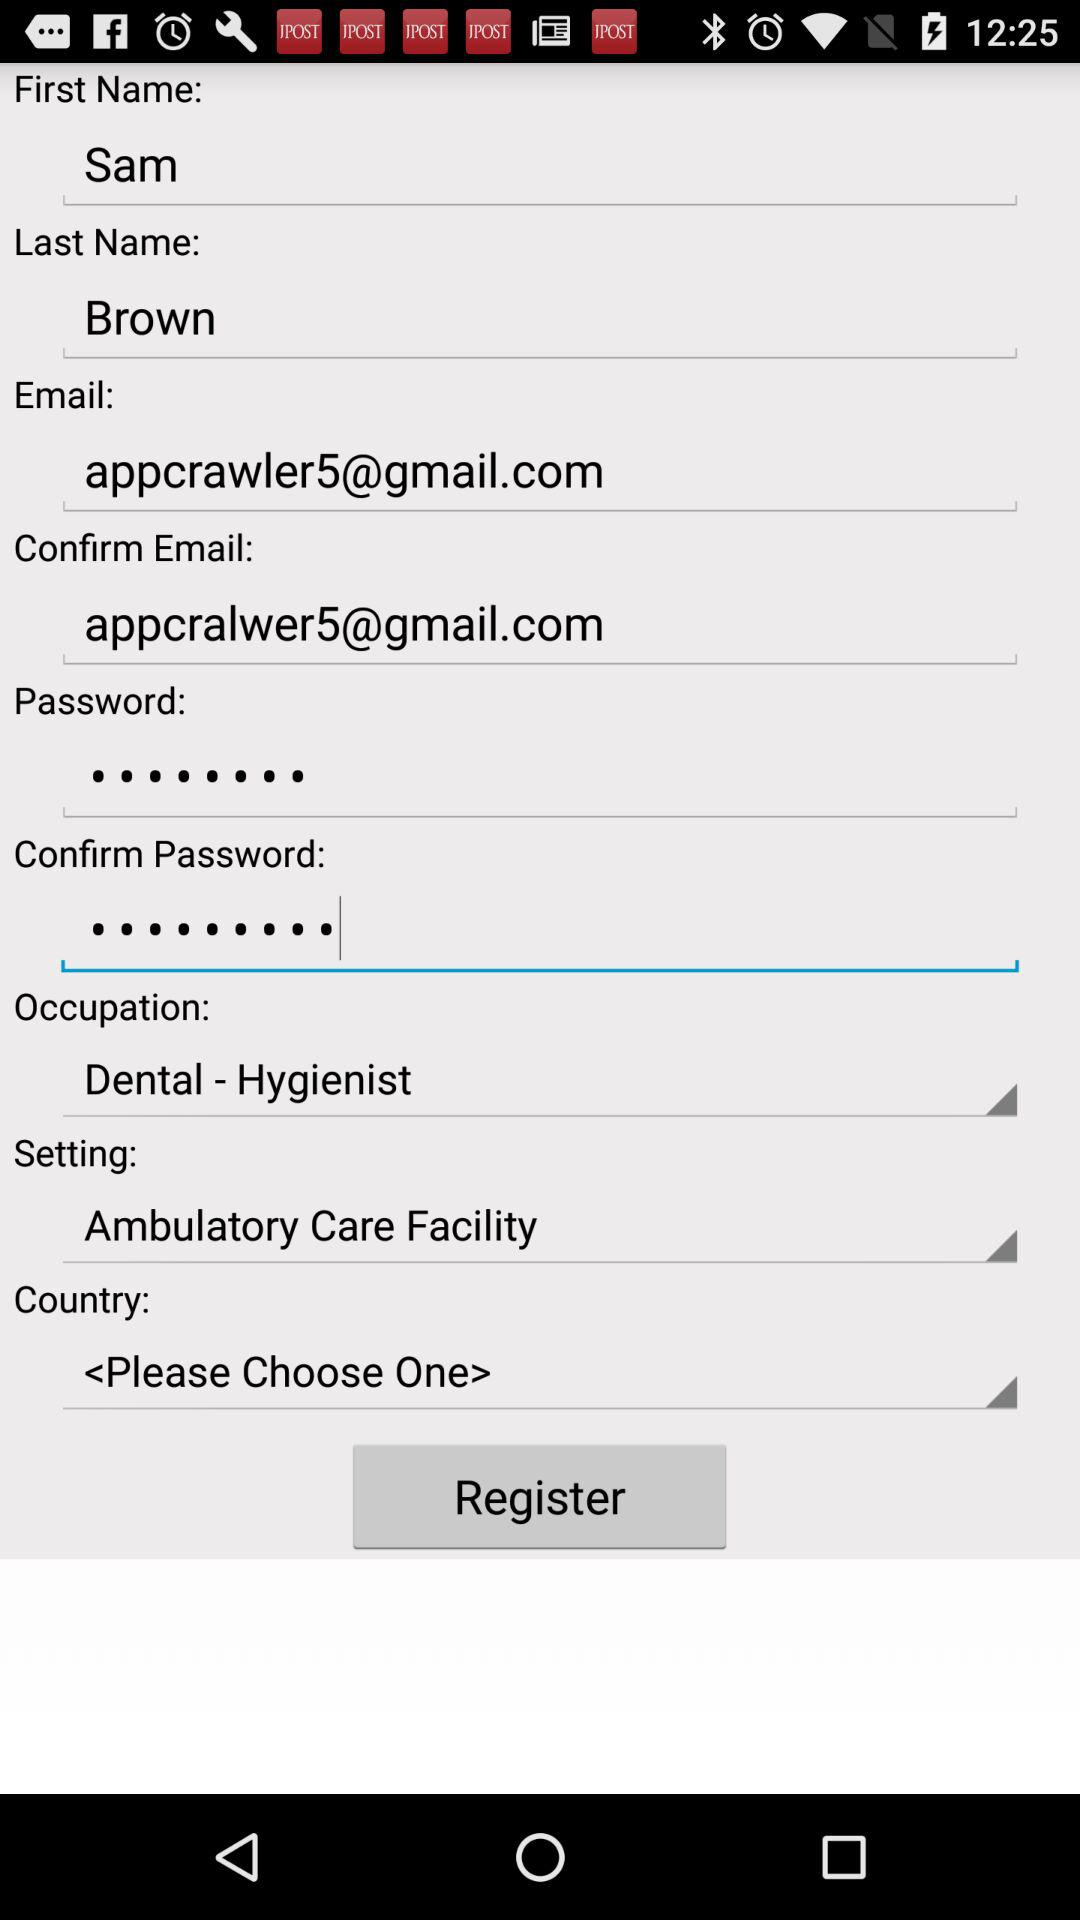What is the email address? The email address is appcrawler5@gmail.com. 